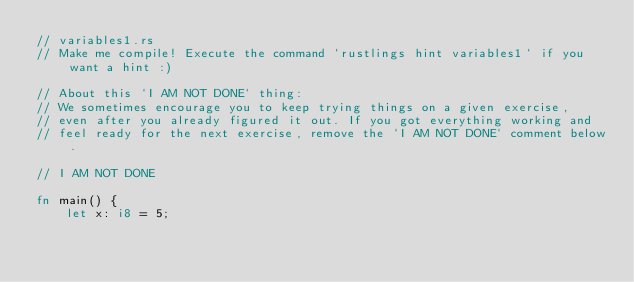<code> <loc_0><loc_0><loc_500><loc_500><_Rust_>// variables1.rs
// Make me compile! Execute the command `rustlings hint variables1` if you want a hint :)

// About this `I AM NOT DONE` thing:
// We sometimes encourage you to keep trying things on a given exercise,
// even after you already figured it out. If you got everything working and
// feel ready for the next exercise, remove the `I AM NOT DONE` comment below.

// I AM NOT DONE

fn main() {
    let x: i8 = 5;</code> 